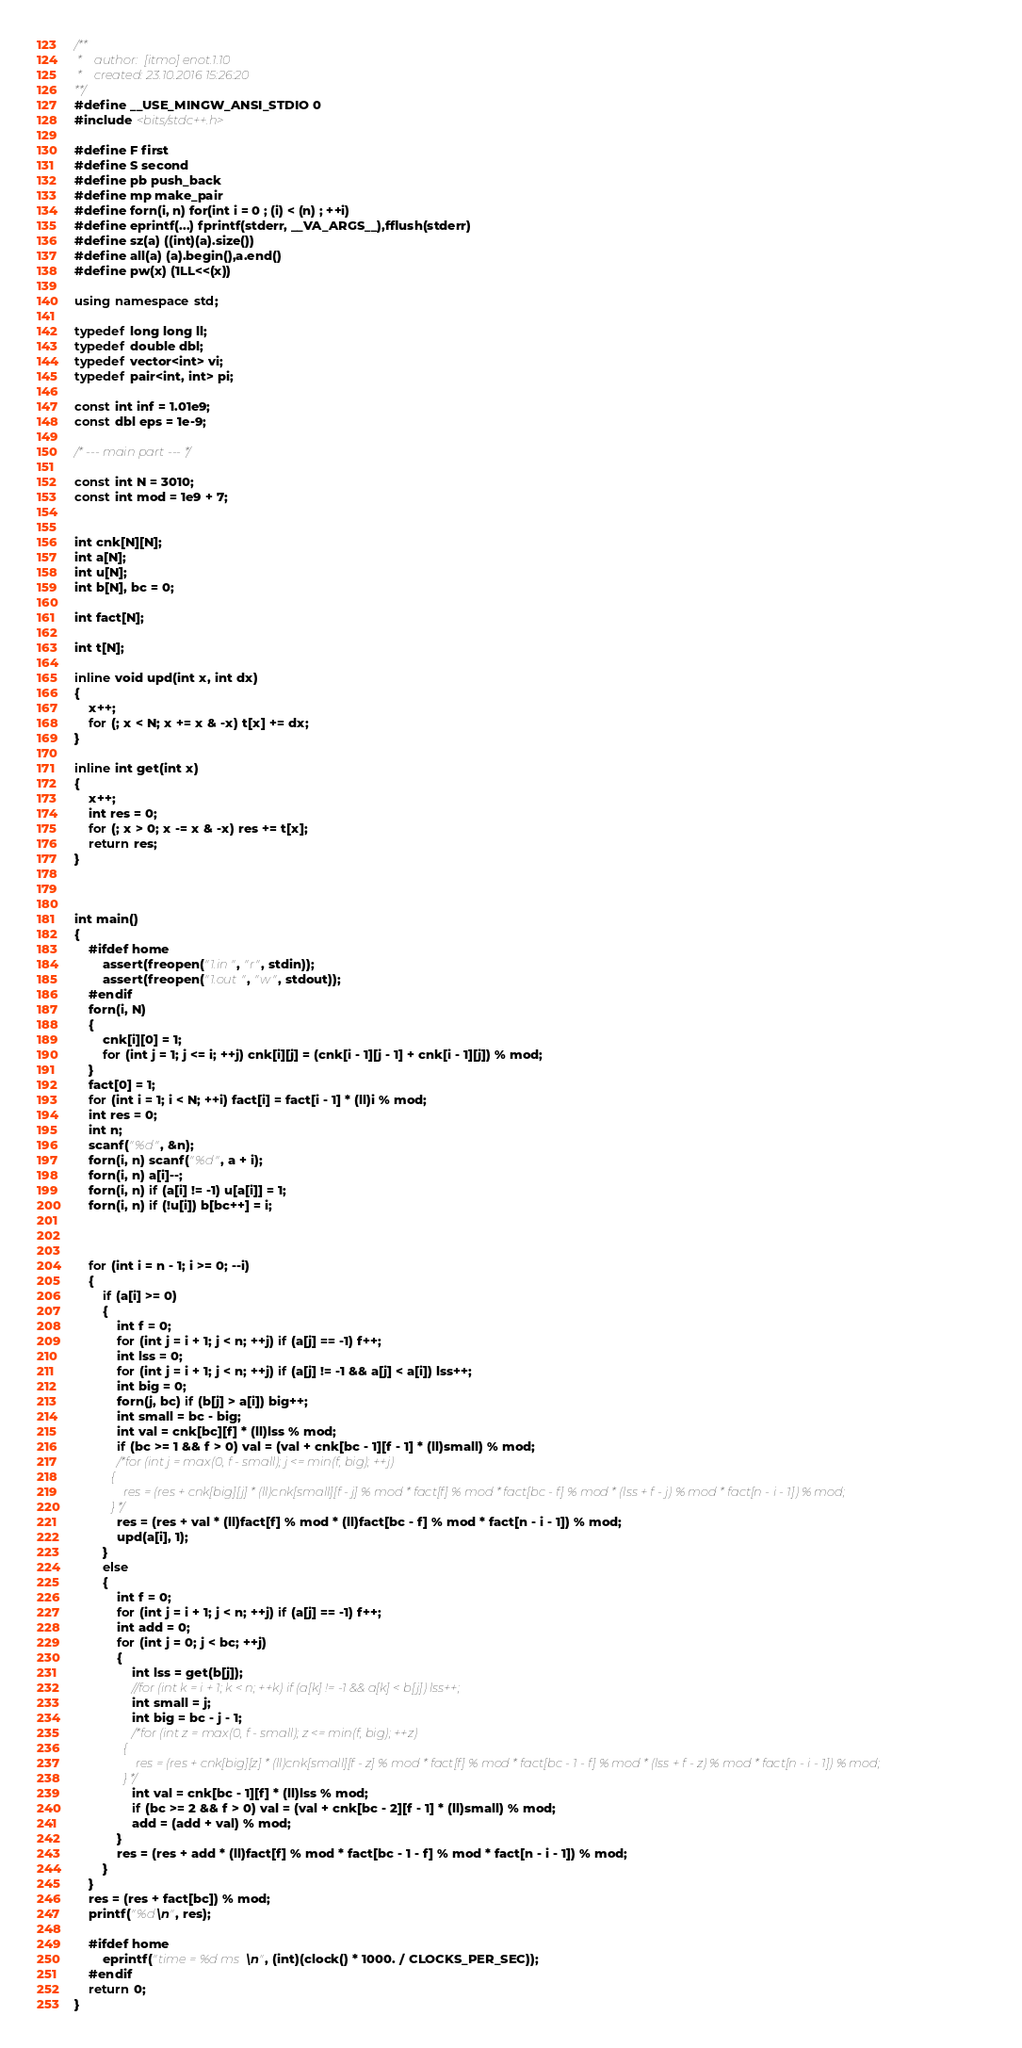Convert code to text. <code><loc_0><loc_0><loc_500><loc_500><_C++_>/**
 *    author:  [itmo] enot.1.10
 *    created: 23.10.2016 15:26:20       
**/
#define __USE_MINGW_ANSI_STDIO 0
#include <bits/stdc++.h>

#define F first
#define S second
#define pb push_back
#define mp make_pair
#define forn(i, n) for(int i = 0 ; (i) < (n) ; ++i)
#define eprintf(...) fprintf(stderr, __VA_ARGS__),fflush(stderr)
#define sz(a) ((int)(a).size())
#define all(a) (a).begin(),a.end()
#define pw(x) (1LL<<(x))

using namespace std;

typedef long long ll;
typedef double dbl;
typedef vector<int> vi;
typedef pair<int, int> pi;

const int inf = 1.01e9;
const dbl eps = 1e-9;

/* --- main part --- */

const int N = 3010;
const int mod = 1e9 + 7;


int cnk[N][N];
int a[N];
int u[N];
int b[N], bc = 0;

int fact[N];

int t[N];

inline void upd(int x, int dx)
{
    x++;
    for (; x < N; x += x & -x) t[x] += dx;
}

inline int get(int x)
{
    x++;
    int res = 0;
    for (; x > 0; x -= x & -x) res += t[x];
    return res;
}



int main()
{
    #ifdef home
        assert(freopen("1.in", "r", stdin));
        assert(freopen("1.out", "w", stdout));
    #endif
    forn(i, N)
    {
        cnk[i][0] = 1;
        for (int j = 1; j <= i; ++j) cnk[i][j] = (cnk[i - 1][j - 1] + cnk[i - 1][j]) % mod;
    }
    fact[0] = 1;
    for (int i = 1; i < N; ++i) fact[i] = fact[i - 1] * (ll)i % mod;
    int res = 0;
    int n;
    scanf("%d", &n);
    forn(i, n) scanf("%d", a + i);
    forn(i, n) a[i]--;
    forn(i, n) if (a[i] != -1) u[a[i]] = 1;
    forn(i, n) if (!u[i]) b[bc++] = i;


    
    for (int i = n - 1; i >= 0; --i)
    {
        if (a[i] >= 0)
        {
            int f = 0;
            for (int j = i + 1; j < n; ++j) if (a[j] == -1) f++;
            int lss = 0;
            for (int j = i + 1; j < n; ++j) if (a[j] != -1 && a[j] < a[i]) lss++;
            int big = 0;
            forn(j, bc) if (b[j] > a[i]) big++;
            int small = bc - big;
            int val = cnk[bc][f] * (ll)lss % mod;
            if (bc >= 1 && f > 0) val = (val + cnk[bc - 1][f - 1] * (ll)small) % mod;
            /*for (int j = max(0, f - small); j <= min(f, big); ++j)
            {
                res = (res + cnk[big][j] * (ll)cnk[small][f - j] % mod * fact[f] % mod * fact[bc - f] % mod * (lss + f - j) % mod * fact[n - i - 1]) % mod;
            } */
            res = (res + val * (ll)fact[f] % mod * (ll)fact[bc - f] % mod * fact[n - i - 1]) % mod;
            upd(a[i], 1);
        }
        else
        {
            int f = 0;
            for (int j = i + 1; j < n; ++j) if (a[j] == -1) f++;
            int add = 0;
            for (int j = 0; j < bc; ++j)
            {
                int lss = get(b[j]);
                //for (int k = i + 1; k < n; ++k) if (a[k] != -1 && a[k] < b[j]) lss++;
                int small = j;
                int big = bc - j - 1;
                /*for (int z = max(0, f - small); z <= min(f, big); ++z)
                {
                    res = (res + cnk[big][z] * (ll)cnk[small][f - z] % mod * fact[f] % mod * fact[bc - 1 - f] % mod * (lss + f - z) % mod * fact[n - i - 1]) % mod;
                } */
                int val = cnk[bc - 1][f] * (ll)lss % mod;
                if (bc >= 2 && f > 0) val = (val + cnk[bc - 2][f - 1] * (ll)small) % mod;
                add = (add + val) % mod;
            }
            res = (res + add * (ll)fact[f] % mod * fact[bc - 1 - f] % mod * fact[n - i - 1]) % mod;
        }
    }
    res = (res + fact[bc]) % mod;
    printf("%d\n", res);
            
    #ifdef home
        eprintf("time = %d ms\n", (int)(clock() * 1000. / CLOCKS_PER_SEC));
    #endif
    return 0;
}
</code> 